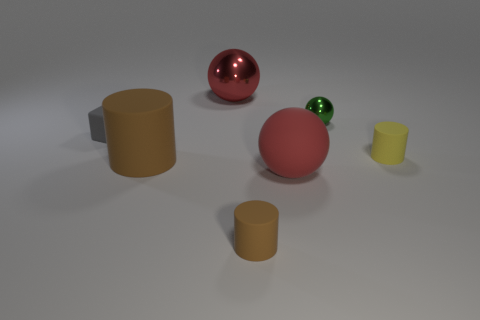Subtract all green balls. How many balls are left? 2 Subtract all cyan blocks. How many red spheres are left? 2 Subtract all yellow cylinders. How many cylinders are left? 2 Add 2 large red metallic balls. How many objects exist? 9 Subtract all cylinders. How many objects are left? 4 Subtract all blue spheres. Subtract all brown cubes. How many spheres are left? 3 Subtract 1 green spheres. How many objects are left? 6 Subtract all small objects. Subtract all red matte blocks. How many objects are left? 3 Add 1 rubber spheres. How many rubber spheres are left? 2 Add 1 large purple matte balls. How many large purple matte balls exist? 1 